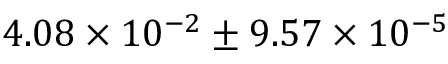<formula> <loc_0><loc_0><loc_500><loc_500>4 . 0 8 \times { 1 0 ^ { - 2 } } \pm 9 . 5 7 \times { 1 0 ^ { - 5 } }</formula> 